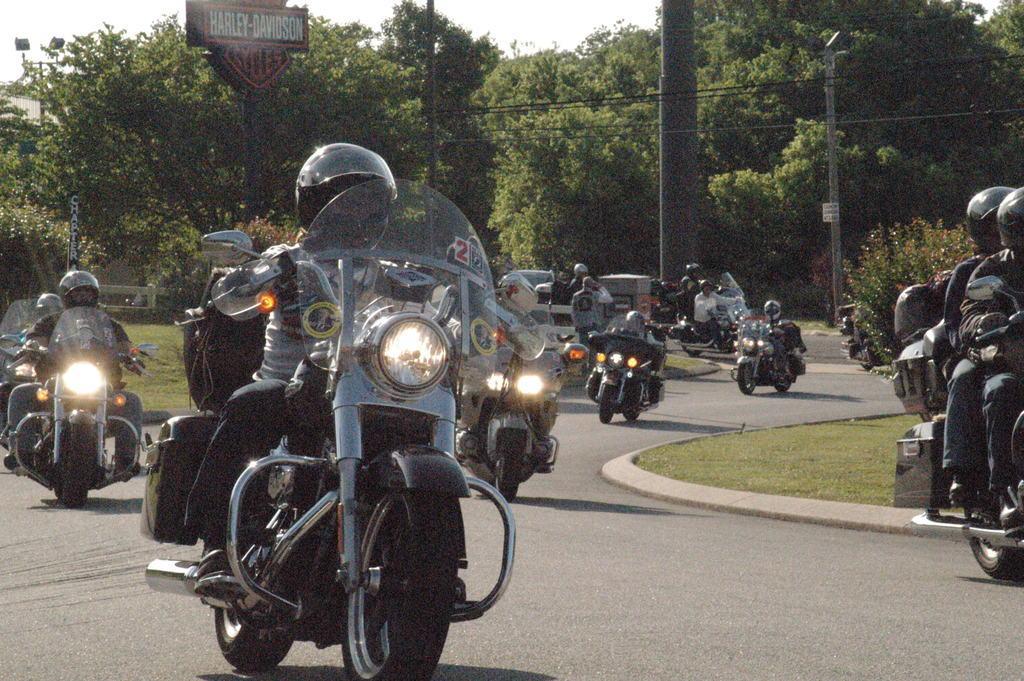Can you describe this image briefly? In this picture i can see people are riding vehicles on the road. These people are wearing helmets. In the background i can see trees and sky. I can also see pokes on which wires are attached to it. On the right side i can see grass and plants. 